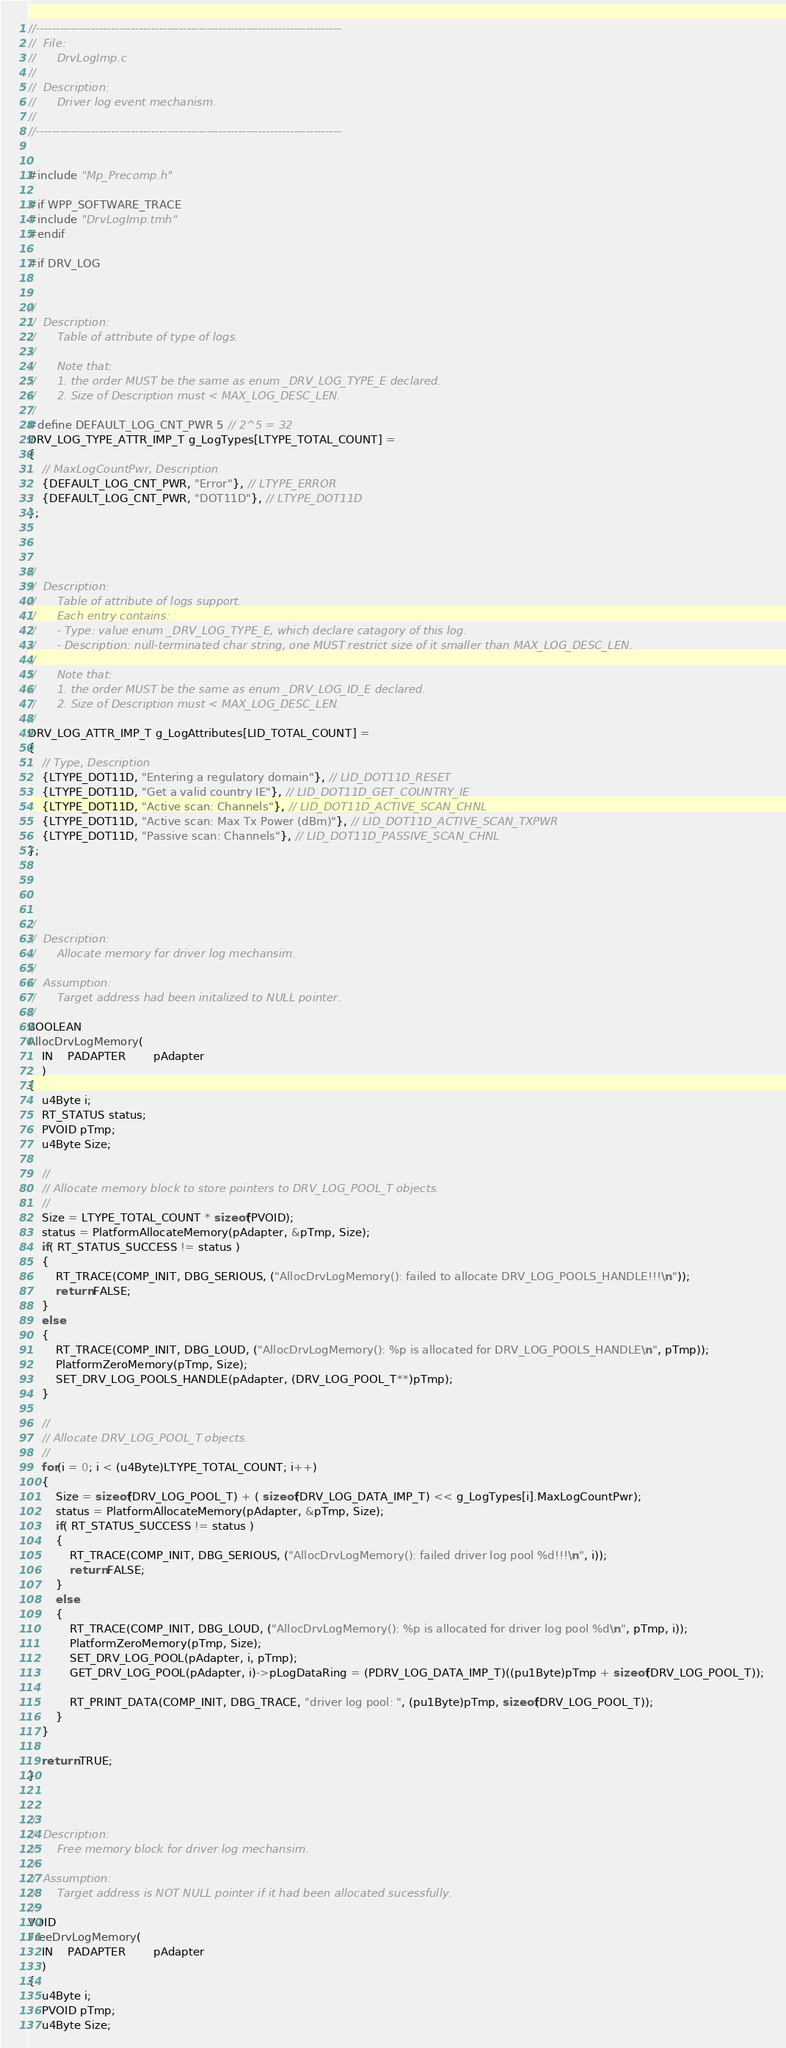Convert code to text. <code><loc_0><loc_0><loc_500><loc_500><_C_>//-----------------------------------------------------------------------------
//	File:
//		DrvLogImp.c
//
//	Description:
//		Driver log event mechanism.	
//
//-----------------------------------------------------------------------------


#include "Mp_Precomp.h"

#if WPP_SOFTWARE_TRACE
#include "DrvLogImp.tmh"
#endif

#if DRV_LOG


//
//	Description:
//		Table of attribute of type of logs. 
//
//		Note that: 
//		1. the order MUST be the same as enum _DRV_LOG_TYPE_E declared.
//		2. Size of Description must < MAX_LOG_DESC_LEN.
//		
#define DEFAULT_LOG_CNT_PWR 5 // 2^5 = 32 
DRV_LOG_TYPE_ATTR_IMP_T g_LogTypes[LTYPE_TOTAL_COUNT] = 
{
	// MaxLogCountPwr, Description
	{DEFAULT_LOG_CNT_PWR, "Error"}, // LTYPE_ERROR
	{DEFAULT_LOG_CNT_PWR, "DOT11D"}, // LTYPE_DOT11D
};



//
//	Description:
//		Table of attribute of logs support.
//		Each entry contains:
//		- Type: value enum _DRV_LOG_TYPE_E, which declare catagory of this log.
//		- Description: null-terminated char string, one MUST restrict size of it smaller than MAX_LOG_DESC_LEN.
//
//		Note that: 
//		1. the order MUST be the same as enum _DRV_LOG_ID_E declared.
//		2. Size of Description must < MAX_LOG_DESC_LEN.
//
DRV_LOG_ATTR_IMP_T g_LogAttributes[LID_TOTAL_COUNT] = 
{
	// Type, Description 
	{LTYPE_DOT11D, "Entering a regulatory domain"}, // LID_DOT11D_RESET
	{LTYPE_DOT11D, "Get a valid country IE"}, // LID_DOT11D_GET_COUNTRY_IE
	{LTYPE_DOT11D, "Active scan: Channels"}, // LID_DOT11D_ACTIVE_SCAN_CHNL
	{LTYPE_DOT11D, "Active scan: Max Tx Power (dBm)"}, // LID_DOT11D_ACTIVE_SCAN_TXPWR
	{LTYPE_DOT11D, "Passive scan: Channels"}, // LID_DOT11D_PASSIVE_SCAN_CHNL
};




//
//	Description:
//		Allocate memory for driver log mechansim. 
//
//	Assumption:
//		Target address had been initalized to NULL pointer.
//
BOOLEAN
AllocDrvLogMemory(
	IN	PADAPTER		pAdapter
	)
{
	u4Byte i;
	RT_STATUS status;
	PVOID pTmp;
	u4Byte Size;

	//
	// Allocate memory block to store pointers to DRV_LOG_POOL_T objects.
	//
	Size = LTYPE_TOTAL_COUNT * sizeof(PVOID);
	status = PlatformAllocateMemory(pAdapter, &pTmp, Size);
	if( RT_STATUS_SUCCESS != status )
	{
		RT_TRACE(COMP_INIT, DBG_SERIOUS, ("AllocDrvLogMemory(): failed to allocate DRV_LOG_POOLS_HANDLE!!!\n"));
		return FALSE;
	}
	else
	{
		RT_TRACE(COMP_INIT, DBG_LOUD, ("AllocDrvLogMemory(): %p is allocated for DRV_LOG_POOLS_HANDLE\n", pTmp));
		PlatformZeroMemory(pTmp, Size);
		SET_DRV_LOG_POOLS_HANDLE(pAdapter, (DRV_LOG_POOL_T**)pTmp);
	}

	//
	// Allocate DRV_LOG_POOL_T objects.
	//
	for(i = 0; i < (u4Byte)LTYPE_TOTAL_COUNT; i++)
	{
		Size = sizeof(DRV_LOG_POOL_T) + ( sizeof(DRV_LOG_DATA_IMP_T) << g_LogTypes[i].MaxLogCountPwr); 
		status = PlatformAllocateMemory(pAdapter, &pTmp, Size);
		if( RT_STATUS_SUCCESS != status )
		{
			RT_TRACE(COMP_INIT, DBG_SERIOUS, ("AllocDrvLogMemory(): failed driver log pool %d!!!\n", i));
			return FALSE;
		}
		else
		{
			RT_TRACE(COMP_INIT, DBG_LOUD, ("AllocDrvLogMemory(): %p is allocated for driver log pool %d\n", pTmp, i));
			PlatformZeroMemory(pTmp, Size);
			SET_DRV_LOG_POOL(pAdapter, i, pTmp);
			GET_DRV_LOG_POOL(pAdapter, i)->pLogDataRing = (PDRV_LOG_DATA_IMP_T)((pu1Byte)pTmp + sizeof(DRV_LOG_POOL_T)); 

			RT_PRINT_DATA(COMP_INIT, DBG_TRACE, "driver log pool: ", (pu1Byte)pTmp, sizeof(DRV_LOG_POOL_T));
		}
	}
	
	return TRUE;
}


//
//	Description:
//		Free memory block for driver log mechansim. 
//
//	Assumption:
//		Target address is NOT NULL pointer if it had been allocated sucessfully. 
//
VOID
FreeDrvLogMemory(
	IN	PADAPTER		pAdapter
	)
{
	u4Byte i;
	PVOID pTmp;
	u4Byte Size;
</code> 